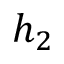<formula> <loc_0><loc_0><loc_500><loc_500>h _ { 2 }</formula> 